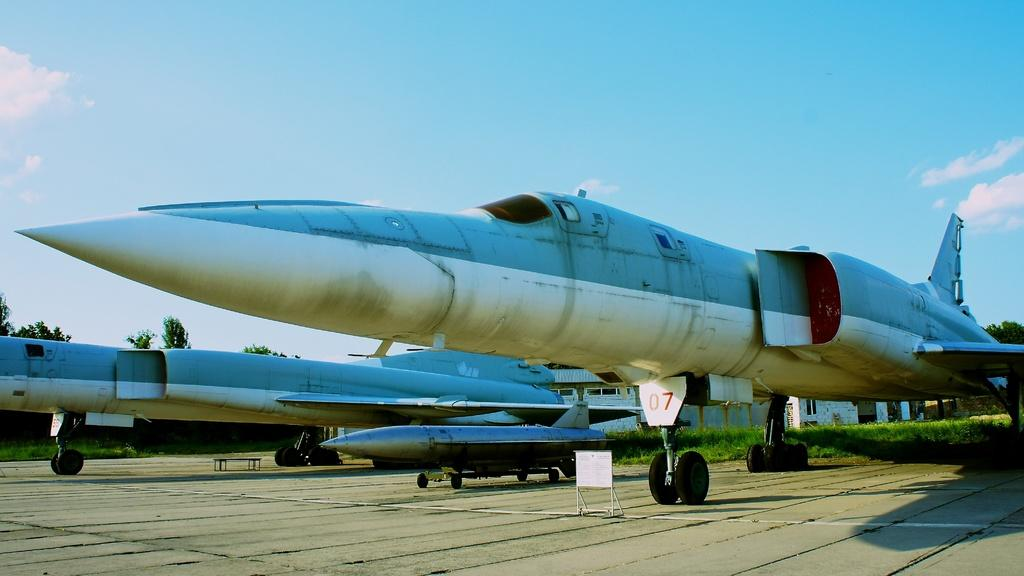<image>
Relay a brief, clear account of the picture shown. a blue and white jet fighter plane has the number 07 by the front wheel 